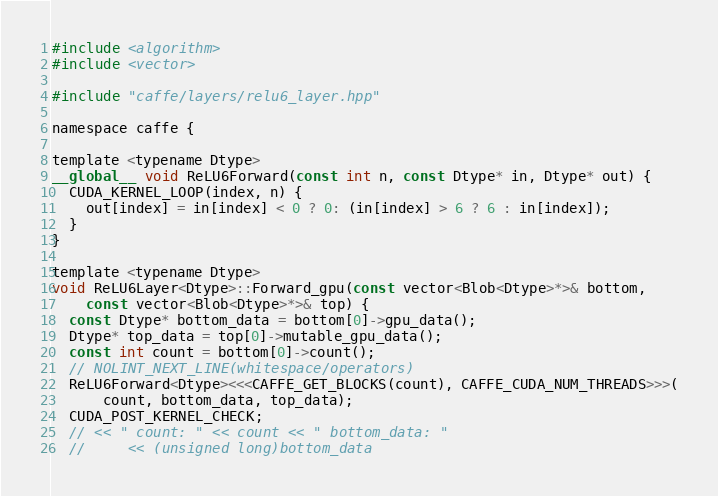Convert code to text. <code><loc_0><loc_0><loc_500><loc_500><_Cuda_>#include <algorithm>
#include <vector>

#include "caffe/layers/relu6_layer.hpp"

namespace caffe {

template <typename Dtype>
__global__ void ReLU6Forward(const int n, const Dtype* in, Dtype* out) {
  CUDA_KERNEL_LOOP(index, n) {
    out[index] = in[index] < 0 ? 0: (in[index] > 6 ? 6 : in[index]);
  }
}

template <typename Dtype>
void ReLU6Layer<Dtype>::Forward_gpu(const vector<Blob<Dtype>*>& bottom,
    const vector<Blob<Dtype>*>& top) {
  const Dtype* bottom_data = bottom[0]->gpu_data();
  Dtype* top_data = top[0]->mutable_gpu_data();
  const int count = bottom[0]->count();
  // NOLINT_NEXT_LINE(whitespace/operators)
  ReLU6Forward<Dtype><<<CAFFE_GET_BLOCKS(count), CAFFE_CUDA_NUM_THREADS>>>(
      count, bottom_data, top_data);
  CUDA_POST_KERNEL_CHECK;
  // << " count: " << count << " bottom_data: "
  //     << (unsigned long)bottom_data</code> 